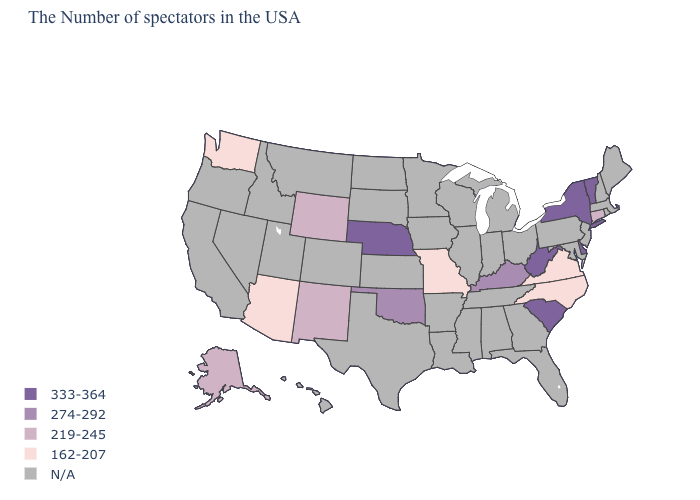Does New Mexico have the highest value in the USA?
Quick response, please. No. What is the value of Maryland?
Be succinct. N/A. Is the legend a continuous bar?
Keep it brief. No. Name the states that have a value in the range 162-207?
Answer briefly. Virginia, North Carolina, Missouri, Arizona, Washington. Name the states that have a value in the range 219-245?
Concise answer only. Connecticut, Wyoming, New Mexico, Alaska. Does Oklahoma have the lowest value in the USA?
Answer briefly. No. What is the value of South Carolina?
Write a very short answer. 333-364. Is the legend a continuous bar?
Write a very short answer. No. Does Delaware have the highest value in the South?
Be succinct. Yes. Does the map have missing data?
Write a very short answer. Yes. Does Connecticut have the lowest value in the USA?
Concise answer only. No. What is the lowest value in states that border Montana?
Short answer required. 219-245. Is the legend a continuous bar?
Be succinct. No. Name the states that have a value in the range 274-292?
Answer briefly. Kentucky, Oklahoma. 